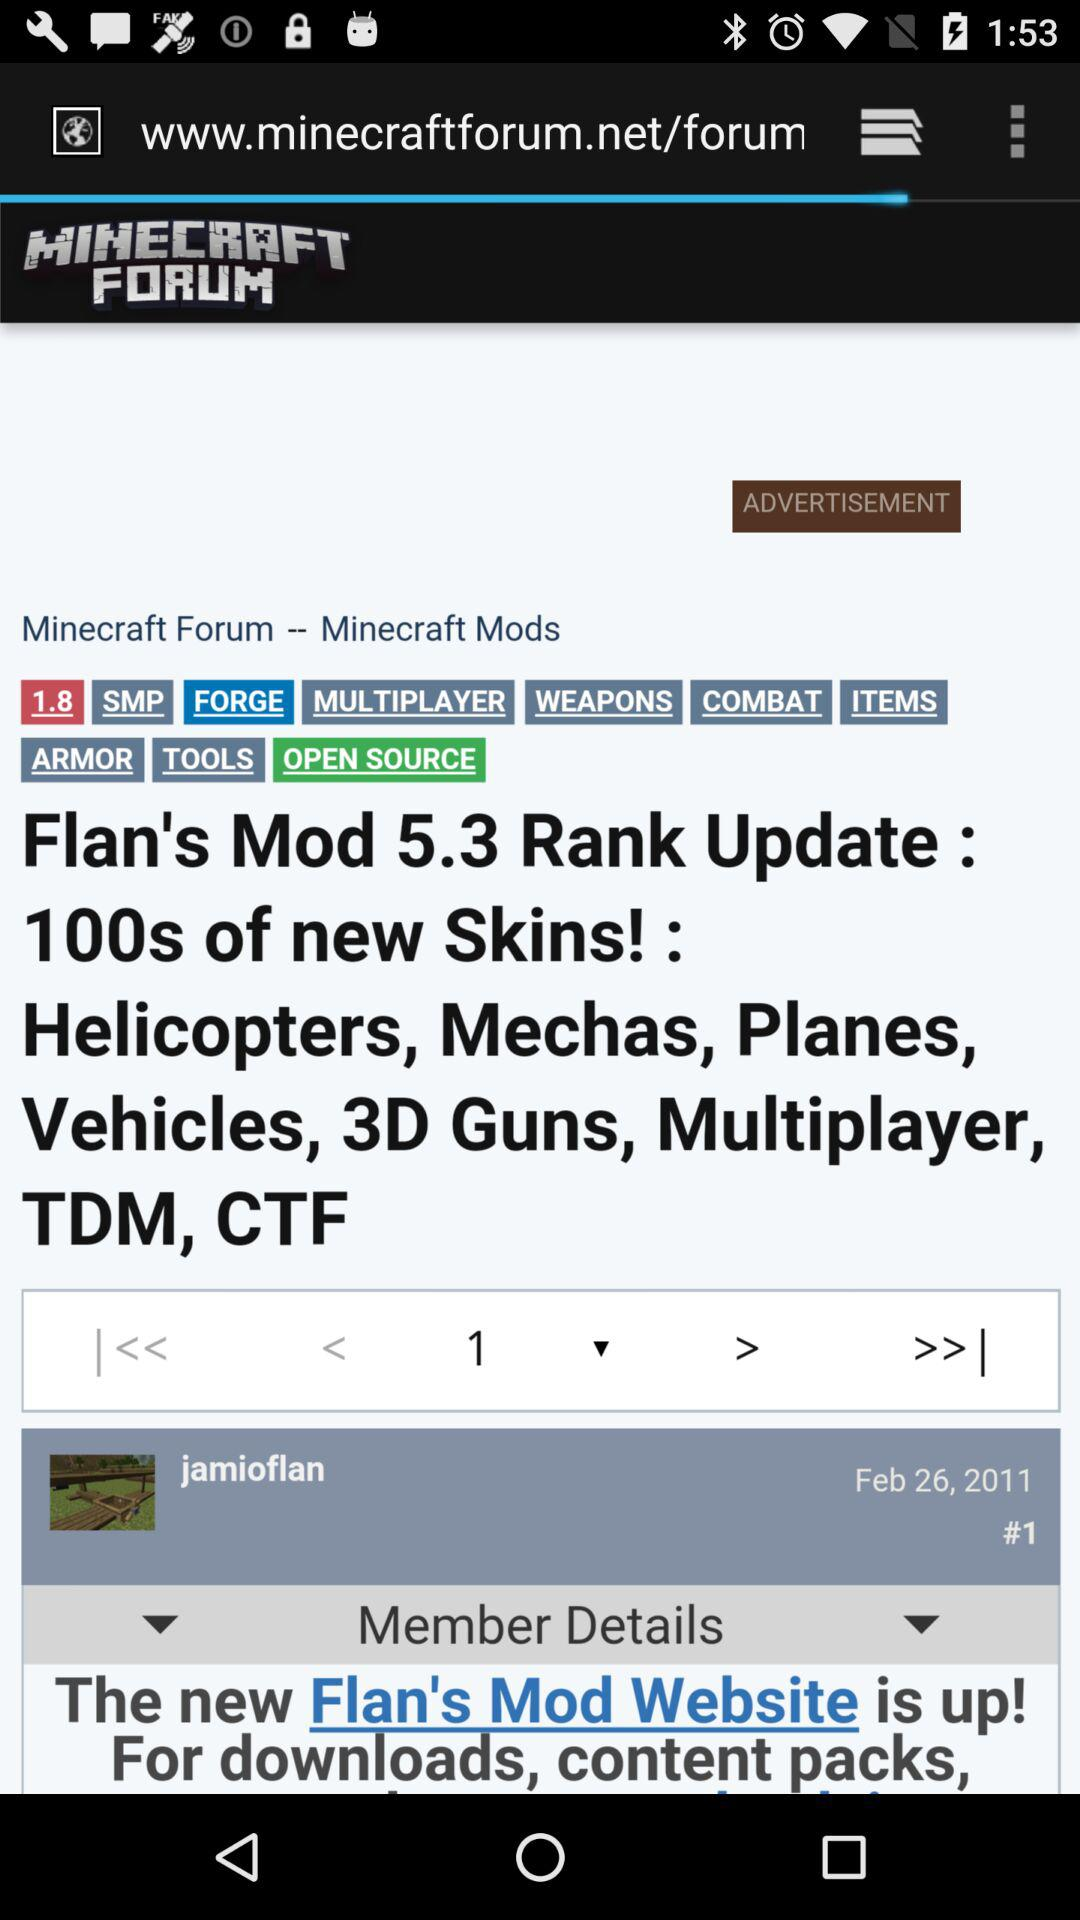What date is displayed on the screen? The displayed date is February 26, 2011. 